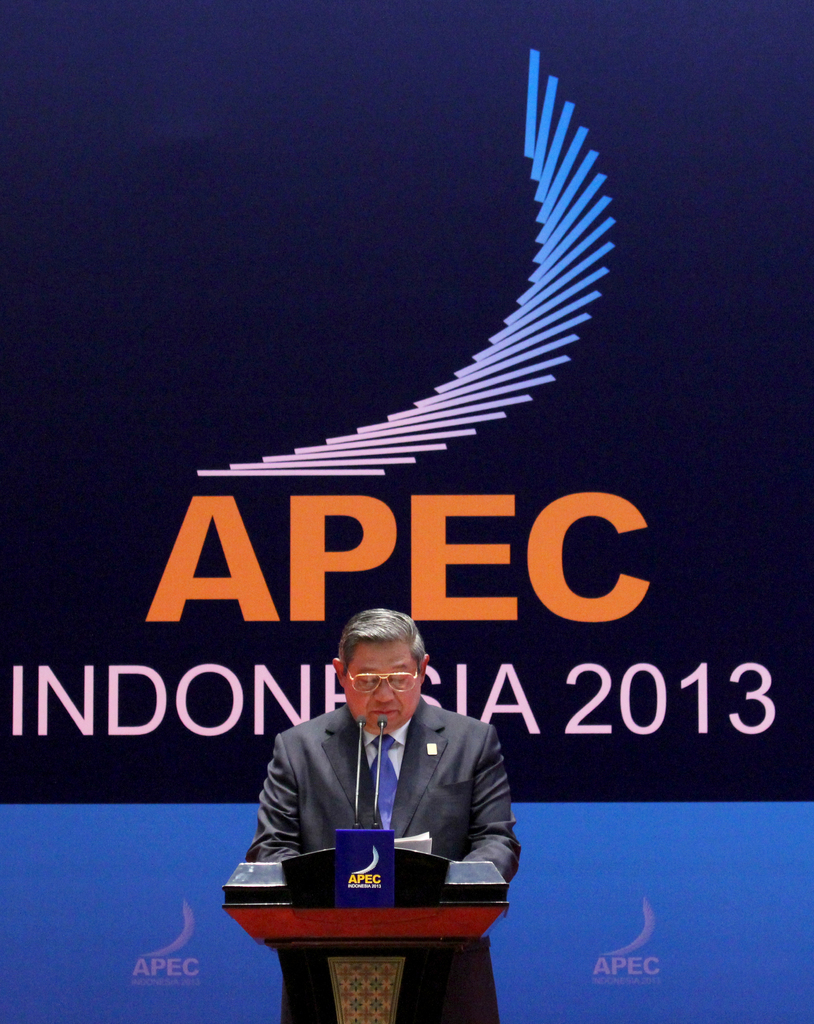Describe the following image. The image shows a distinguished man delivering a speech at the APEC Indonesia 2013 conference. Clad in a formal suit and glasses, he stands behind a wooden podium adorned with the APEC logo. The backdrop is a deep blue with 'APEC INDONESIA 2013' prominently featured, which tells us the event and its geographic importance. His attentive engagement with the microphone underscores a moment of significant communication, likely addressing critical regional economic strategies and international collaboration efforts. This scene encapsulates a pivotal moment in Asia-Pacific diplomacy, highlighting the role of such conferences in shaping global economic policies. 